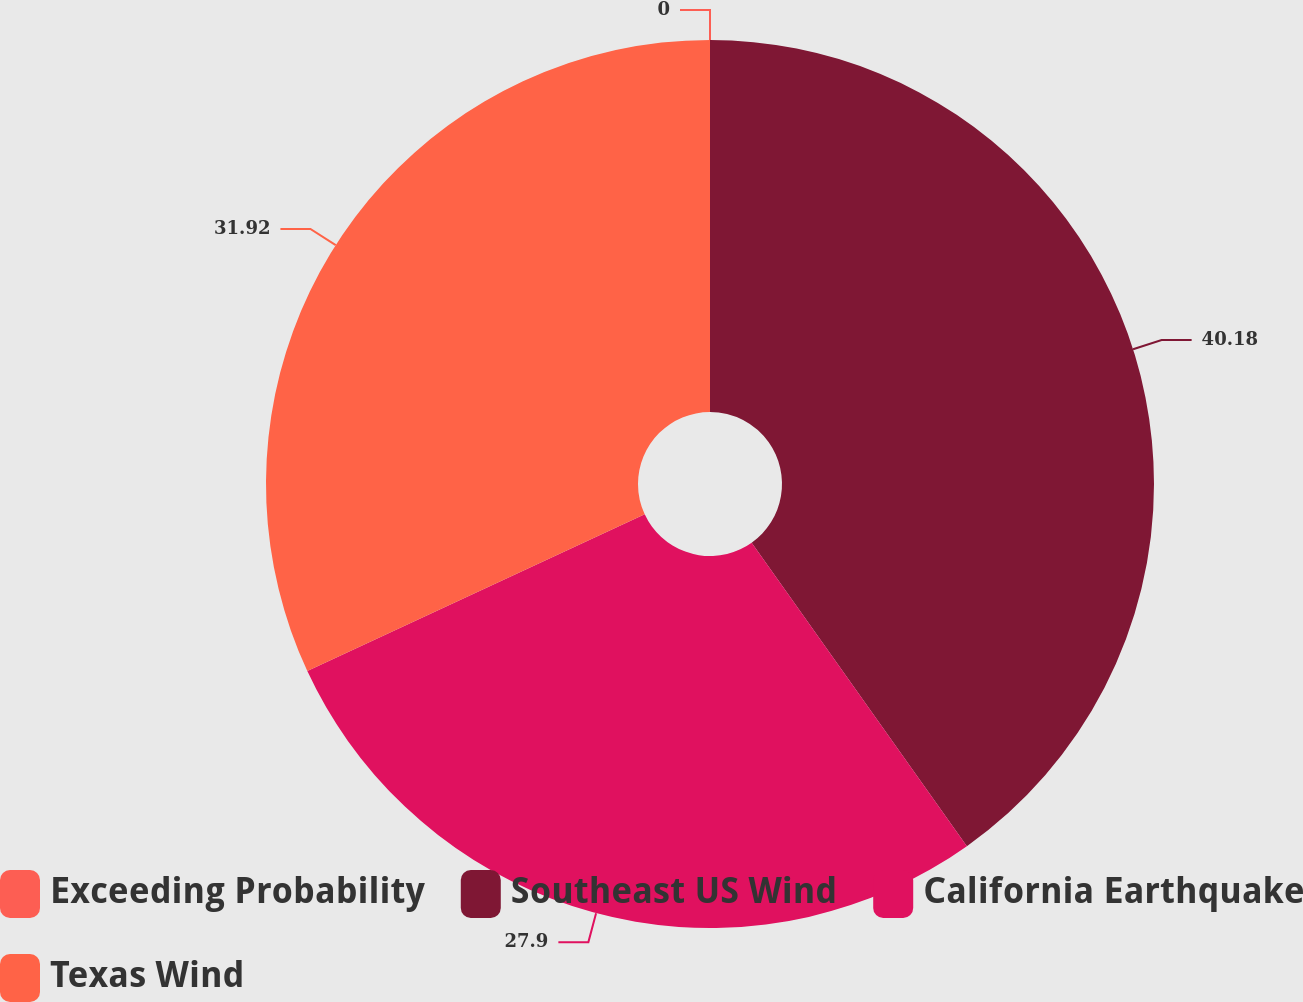Convert chart to OTSL. <chart><loc_0><loc_0><loc_500><loc_500><pie_chart><fcel>Exceeding Probability<fcel>Southeast US Wind<fcel>California Earthquake<fcel>Texas Wind<nl><fcel>0.0%<fcel>40.18%<fcel>27.9%<fcel>31.92%<nl></chart> 